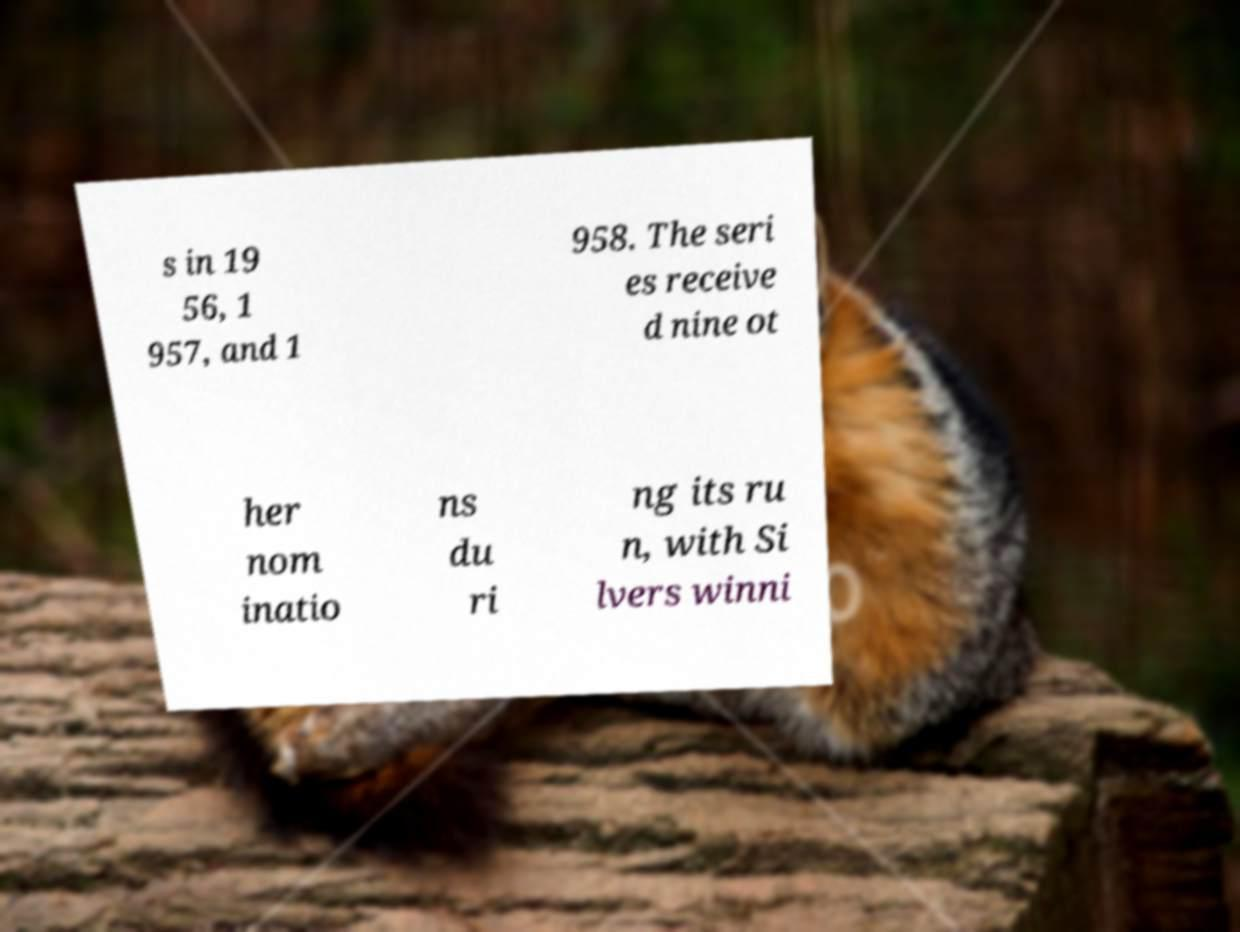Can you accurately transcribe the text from the provided image for me? s in 19 56, 1 957, and 1 958. The seri es receive d nine ot her nom inatio ns du ri ng its ru n, with Si lvers winni 